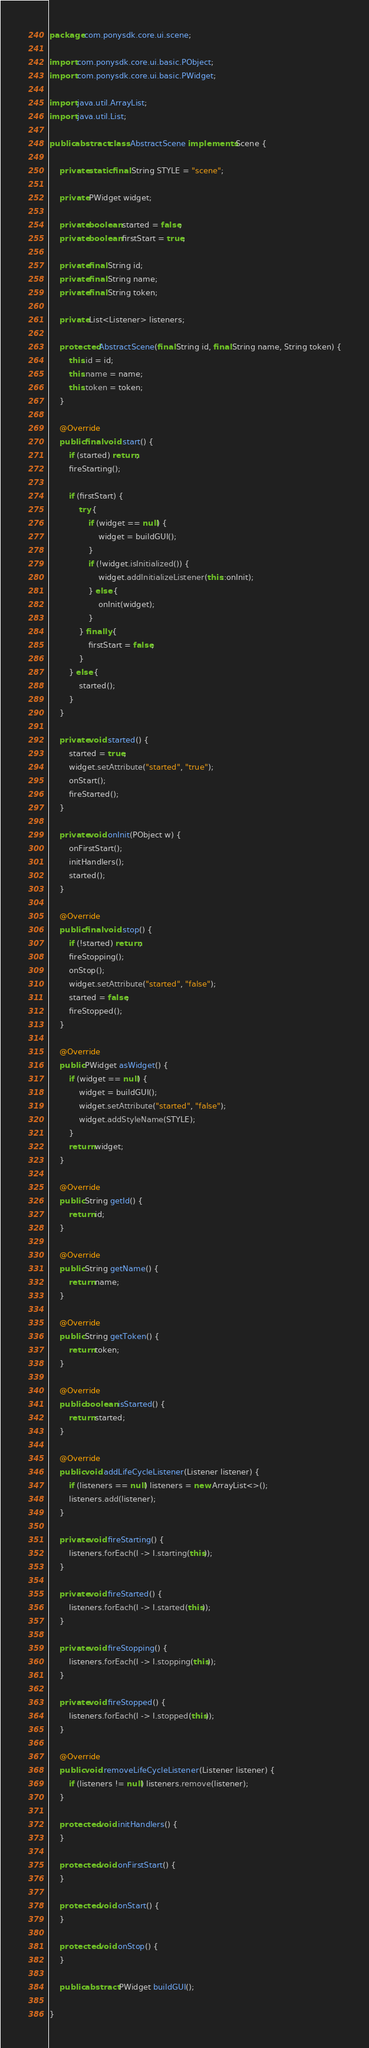Convert code to text. <code><loc_0><loc_0><loc_500><loc_500><_Java_>
package com.ponysdk.core.ui.scene;

import com.ponysdk.core.ui.basic.PObject;
import com.ponysdk.core.ui.basic.PWidget;

import java.util.ArrayList;
import java.util.List;

public abstract class AbstractScene implements Scene {

    private static final String STYLE = "scene";

    private PWidget widget;

    private boolean started = false;
    private boolean firstStart = true;

    private final String id;
    private final String name;
    private final String token;

    private List<Listener> listeners;

    protected AbstractScene(final String id, final String name, String token) {
        this.id = id;
        this.name = name;
        this.token = token;
    }

    @Override
    public final void start() {
        if (started) return;
        fireStarting();

        if (firstStart) {
            try {
                if (widget == null) {
                    widget = buildGUI();
                }
                if (!widget.isInitialized()) {
                    widget.addInitializeListener(this::onInit);
                } else {
                    onInit(widget);
                }
            } finally {
                firstStart = false;
            }
        } else {
            started();
        }
    }

    private void started() {
        started = true;
        widget.setAttribute("started", "true");
        onStart();
        fireStarted();
    }

    private void onInit(PObject w) {
        onFirstStart();
        initHandlers();
        started();
    }

    @Override
    public final void stop() {
        if (!started) return;
        fireStopping();
        onStop();
        widget.setAttribute("started", "false");
        started = false;
        fireStopped();
    }

    @Override
    public PWidget asWidget() {
        if (widget == null) {
            widget = buildGUI();
            widget.setAttribute("started", "false");
            widget.addStyleName(STYLE);
        }
        return widget;
    }

    @Override
    public String getId() {
        return id;
    }

    @Override
    public String getName() {
        return name;
    }

    @Override
    public String getToken() {
        return token;
    }

    @Override
    public boolean isStarted() {
        return started;
    }

    @Override
    public void addLifeCycleListener(Listener listener) {
        if (listeners == null) listeners = new ArrayList<>();
        listeners.add(listener);
    }

    private void fireStarting() {
        listeners.forEach(l -> l.starting(this));
    }

    private void fireStarted() {
        listeners.forEach(l -> l.started(this));
    }

    private void fireStopping() {
        listeners.forEach(l -> l.stopping(this));
    }

    private void fireStopped() {
        listeners.forEach(l -> l.stopped(this));
    }

    @Override
    public void removeLifeCycleListener(Listener listener) {
        if (listeners != null) listeners.remove(listener);
    }

    protected void initHandlers() {
    }

    protected void onFirstStart() {
    }

    protected void onStart() {
    }

    protected void onStop() {
    }

    public abstract PWidget buildGUI();

}
</code> 